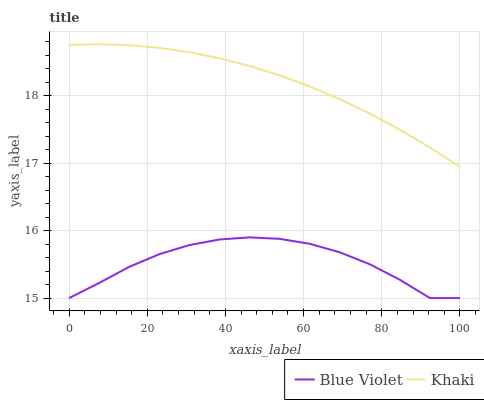Does Blue Violet have the minimum area under the curve?
Answer yes or no. Yes. Does Khaki have the maximum area under the curve?
Answer yes or no. Yes. Does Blue Violet have the maximum area under the curve?
Answer yes or no. No. Is Khaki the smoothest?
Answer yes or no. Yes. Is Blue Violet the roughest?
Answer yes or no. Yes. Is Blue Violet the smoothest?
Answer yes or no. No. Does Blue Violet have the lowest value?
Answer yes or no. Yes. Does Khaki have the highest value?
Answer yes or no. Yes. Does Blue Violet have the highest value?
Answer yes or no. No. Is Blue Violet less than Khaki?
Answer yes or no. Yes. Is Khaki greater than Blue Violet?
Answer yes or no. Yes. Does Blue Violet intersect Khaki?
Answer yes or no. No. 